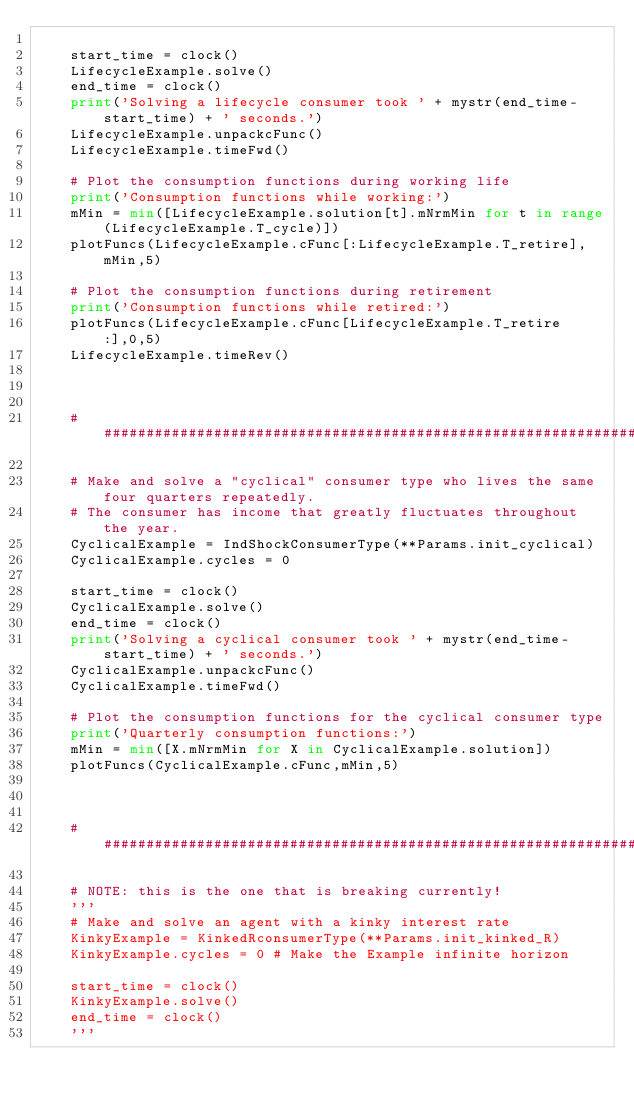Convert code to text. <code><loc_0><loc_0><loc_500><loc_500><_Python_>
    start_time = clock()
    LifecycleExample.solve()
    end_time = clock()
    print('Solving a lifecycle consumer took ' + mystr(end_time-start_time) + ' seconds.')
    LifecycleExample.unpackcFunc()
    LifecycleExample.timeFwd()

    # Plot the consumption functions during working life
    print('Consumption functions while working:')
    mMin = min([LifecycleExample.solution[t].mNrmMin for t in range(LifecycleExample.T_cycle)])
    plotFuncs(LifecycleExample.cFunc[:LifecycleExample.T_retire],mMin,5)

    # Plot the consumption functions during retirement
    print('Consumption functions while retired:')
    plotFuncs(LifecycleExample.cFunc[LifecycleExample.T_retire:],0,5)
    LifecycleExample.timeRev()



    ###############################################################################        
        
    # Make and solve a "cyclical" consumer type who lives the same four quarters repeatedly.
    # The consumer has income that greatly fluctuates throughout the year.
    CyclicalExample = IndShockConsumerType(**Params.init_cyclical)
    CyclicalExample.cycles = 0

    start_time = clock()
    CyclicalExample.solve()
    end_time = clock()
    print('Solving a cyclical consumer took ' + mystr(end_time-start_time) + ' seconds.')
    CyclicalExample.unpackcFunc()
    CyclicalExample.timeFwd()

    # Plot the consumption functions for the cyclical consumer type
    print('Quarterly consumption functions:')
    mMin = min([X.mNrmMin for X in CyclicalExample.solution])
    plotFuncs(CyclicalExample.cFunc,mMin,5)



    ###############################################################################

    # NOTE: this is the one that is breaking currently!
    '''
    # Make and solve an agent with a kinky interest rate
    KinkyExample = KinkedRconsumerType(**Params.init_kinked_R)
    KinkyExample.cycles = 0 # Make the Example infinite horizon

    start_time = clock()
    KinkyExample.solve()
    end_time = clock()
    '''

</code> 